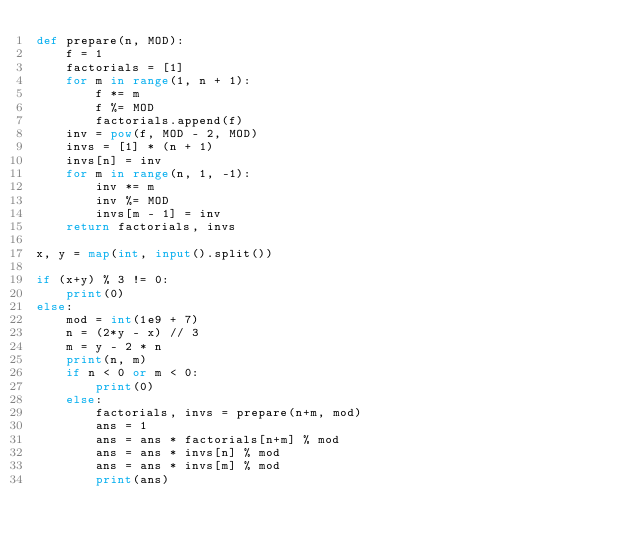Convert code to text. <code><loc_0><loc_0><loc_500><loc_500><_Python_>def prepare(n, MOD):
    f = 1
    factorials = [1]
    for m in range(1, n + 1):
        f *= m
        f %= MOD
        factorials.append(f)
    inv = pow(f, MOD - 2, MOD)
    invs = [1] * (n + 1)
    invs[n] = inv
    for m in range(n, 1, -1):
        inv *= m
        inv %= MOD
        invs[m - 1] = inv
    return factorials, invs

x, y = map(int, input().split())

if (x+y) % 3 != 0:
    print(0)
else:
    mod = int(1e9 + 7)
    n = (2*y - x) // 3
    m = y - 2 * n
    print(n, m)
    if n < 0 or m < 0:
        print(0)
    else:
        factorials, invs = prepare(n+m, mod)
        ans = 1
        ans = ans * factorials[n+m] % mod
        ans = ans * invs[n] % mod
        ans = ans * invs[m] % mod
        print(ans)</code> 